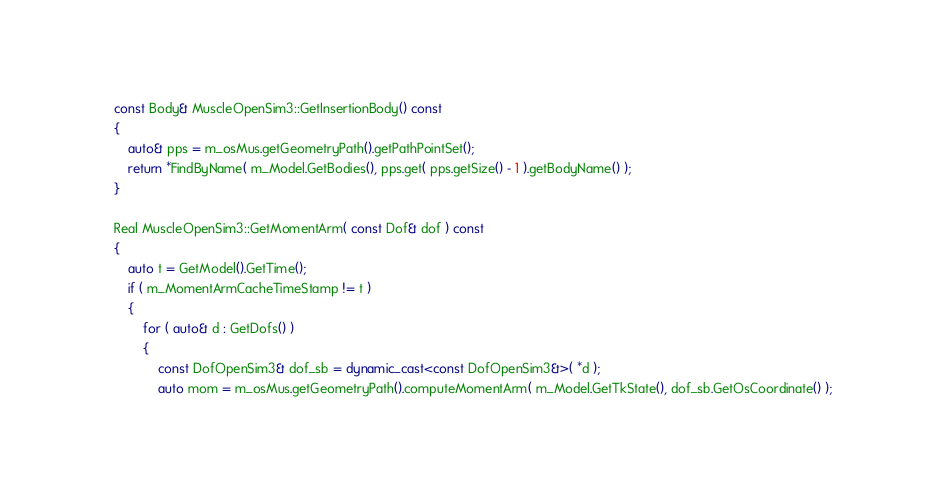Convert code to text. <code><loc_0><loc_0><loc_500><loc_500><_C++_>
	const Body& MuscleOpenSim3::GetInsertionBody() const
	{
		auto& pps = m_osMus.getGeometryPath().getPathPointSet();
		return *FindByName( m_Model.GetBodies(), pps.get( pps.getSize() - 1 ).getBodyName() );
	}

	Real MuscleOpenSim3::GetMomentArm( const Dof& dof ) const
	{
		auto t = GetModel().GetTime();
		if ( m_MomentArmCacheTimeStamp != t )
		{
			for ( auto& d : GetDofs() )
			{
				const DofOpenSim3& dof_sb = dynamic_cast<const DofOpenSim3&>( *d );
				auto mom = m_osMus.getGeometryPath().computeMomentArm( m_Model.GetTkState(), dof_sb.GetOsCoordinate() );</code> 